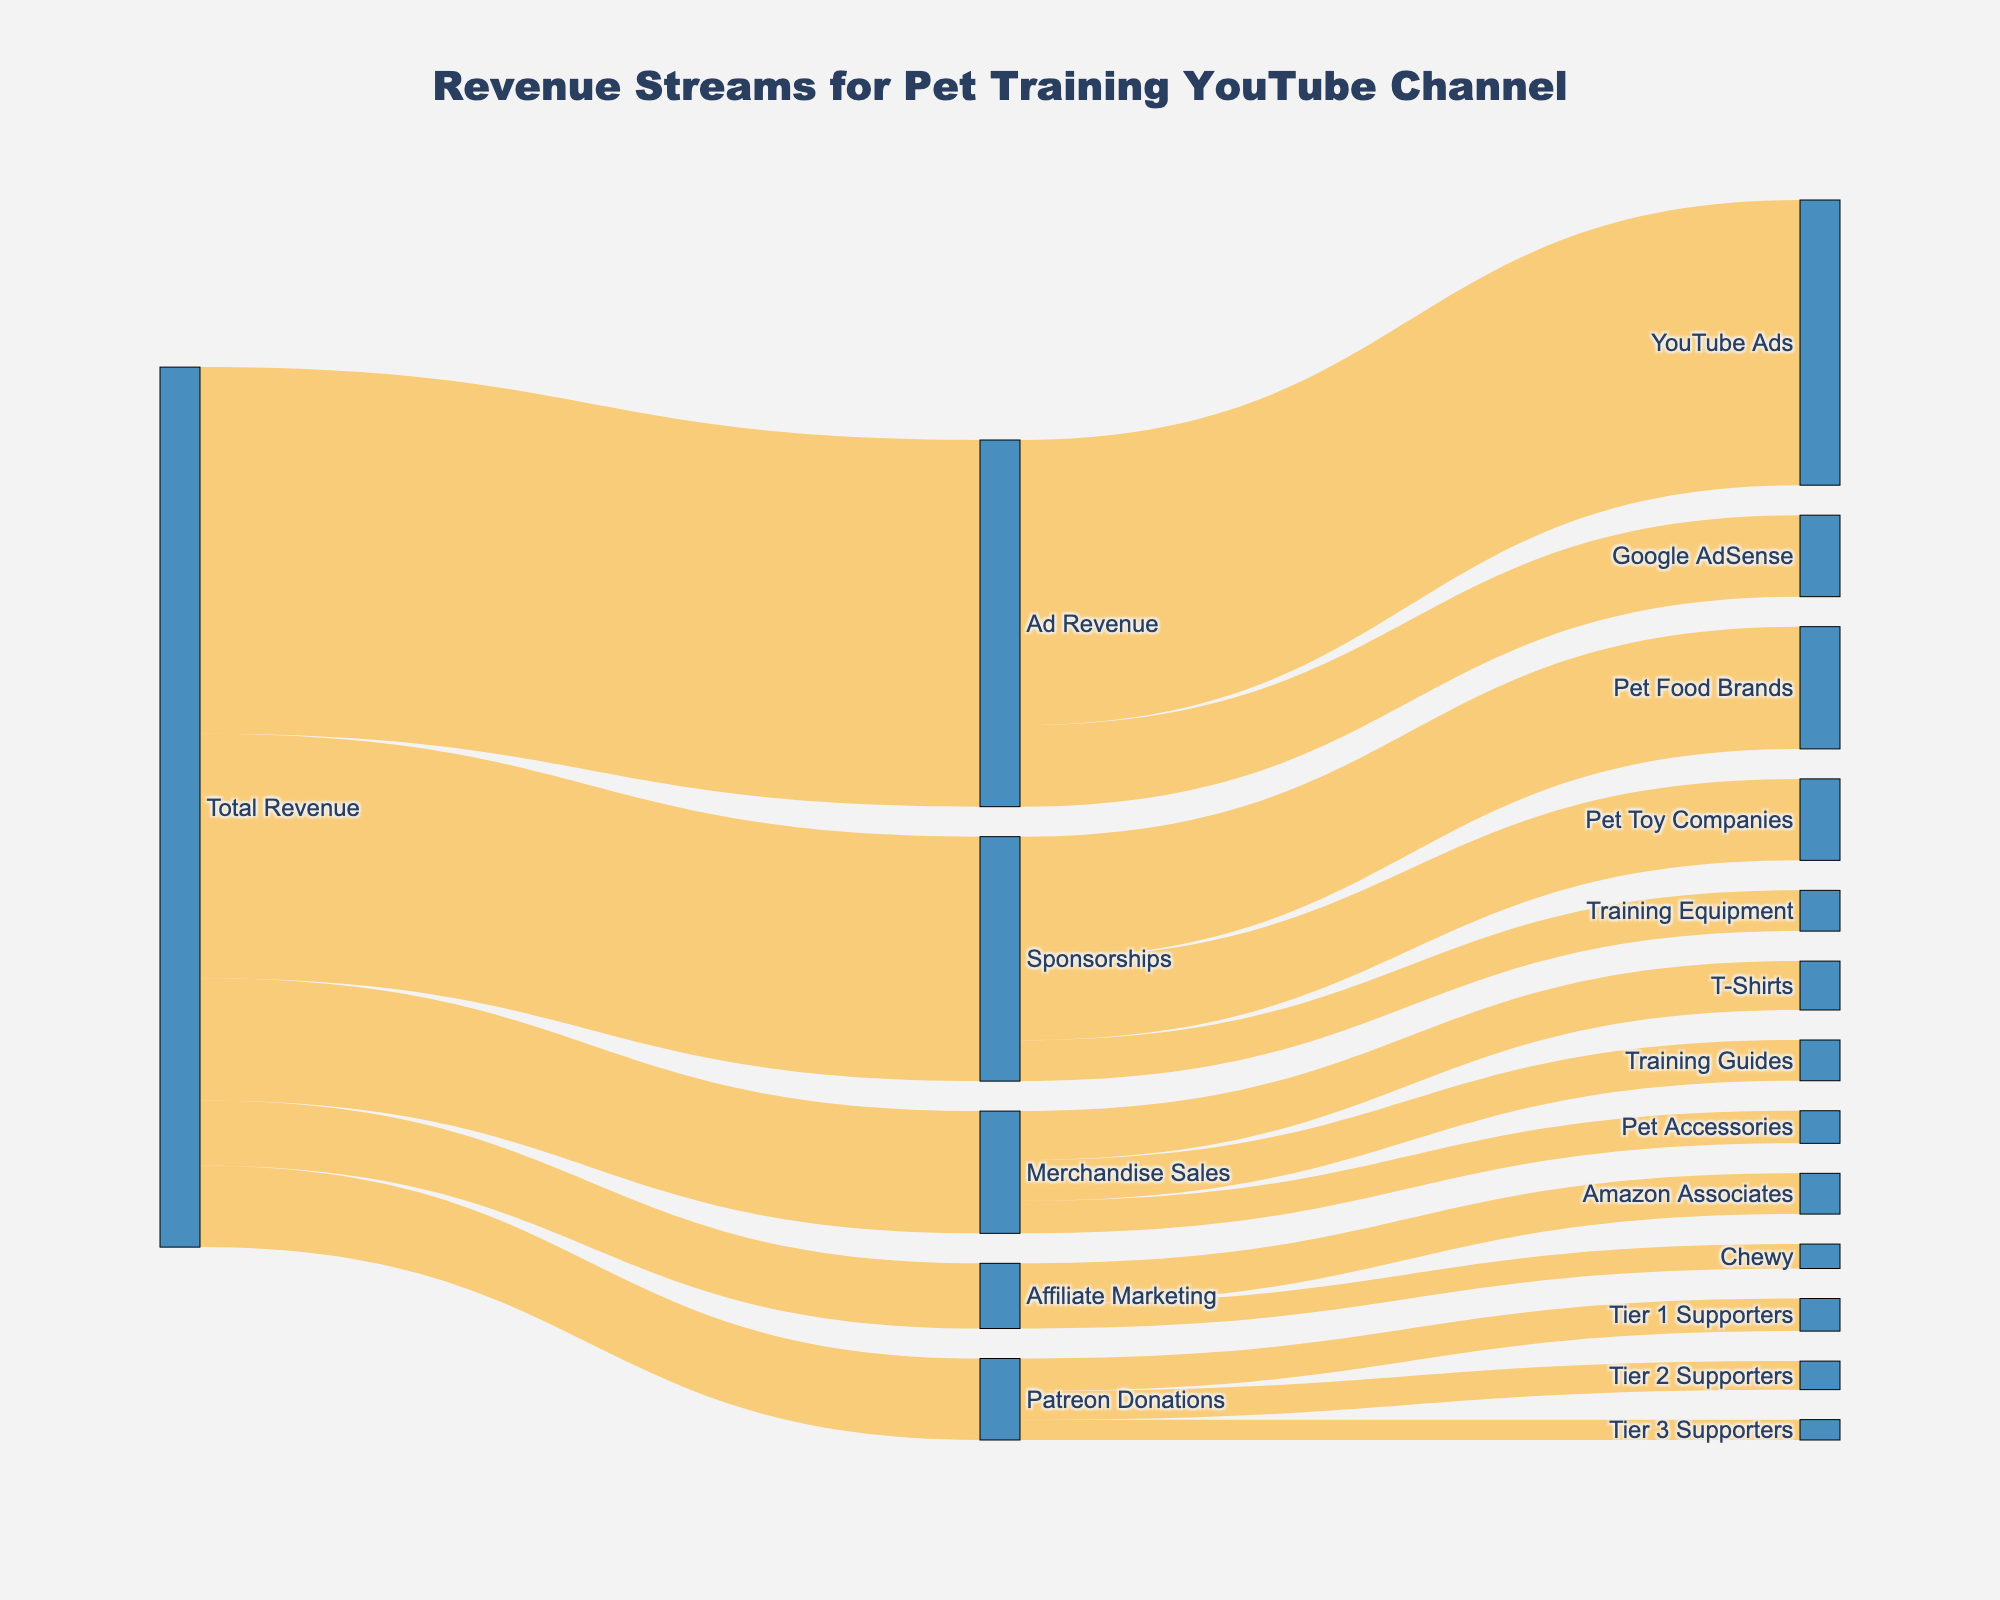What is the total revenue for the pet training YouTube channel? The total revenue is represented by the "Total Revenue" node in the diagram, from which all other revenue streams originate. The sum of all outgoing flows from this node determines the total revenue. By adding up all the outgoing values (45000 + 30000 + 15000 + 10000 + 8000), we get 108000.
Answer: 108000 Which revenue stream contributes the most to the total revenue? The revenue stream with the largest outgoing value from the "Total Revenue" node is the one that contributes the most. Ad Revenue has the highest value, which is 45000.
Answer: Ad Revenue How much revenue does YouTube ads generate within Ad Revenue? Under the "Ad Revenue" node, there are two streams: YouTube Ads and Google AdSense. The value associated with YouTube Ads is 35000.
Answer: 35000 What is the combined revenue from Sponsorships and Merchandise Sales? To find the combined revenue from Sponsorships and Merchandise Sales, add their respective values under the "Total Revenue" node. Sponsorships contribute 30000 and Merchandise Sales contribute 15000, so the combined total is 30000 + 15000 = 45000.
Answer: 45000 Which has a higher revenue within Sponsorships: Pet Food Brands or Pet Toy Companies? Under the "Sponsorships" node, compare the values of Pet Food Brands and Pet Toy Companies. Pet Food Brands is 15000, and Pet Toy Companies is 10000. Pet Food Brands has a higher revenue.
Answer: Pet Food Brands How much revenue comes from Patreon Donations and what are its sub-streams' values? Patreon Donations has a total value and also individual values for its sub-streams. The total revenue from Patreon Donations is 10000. The sub-stream values are Tier 1 Supporters - 4000, Tier 2 Supporters - 3500, and Tier 3 Supporters - 2500.
Answer: 10000 (sub-streams: 4000, 3500, 2500) Which sub-stream under Merchandise Sales contributes the least? Within the "Merchandise Sales" node, the sub-streams are T-Shirts, Training Guides, and Pet Accessories. Their respective values are 6000, 5000, and 4000. Pet Accessories has the lowest contribution.
Answer: Pet Accessories What is the total revenue from Affiliate Marketing and its sub-streams? The total revenue from Affiliate Marketing is given by the "Total Revenue" to Affiliate Marketing flow. The total value is 8000. Its sub-streams are Amazon Associates and Chewy, with values of 5000 and 3000 respectively.
Answer: 8000 (sub-streams: 5000, 3000) Between Google AdSense and Amazon Associates, which contributes more and by how much? First, find the individual values for Google AdSense and Amazon Associates. Google AdSense is 10000, and Amazon Associates is 5000. The difference is 10000 - 5000 = 5000.
Answer: Google AdSense by 5000 